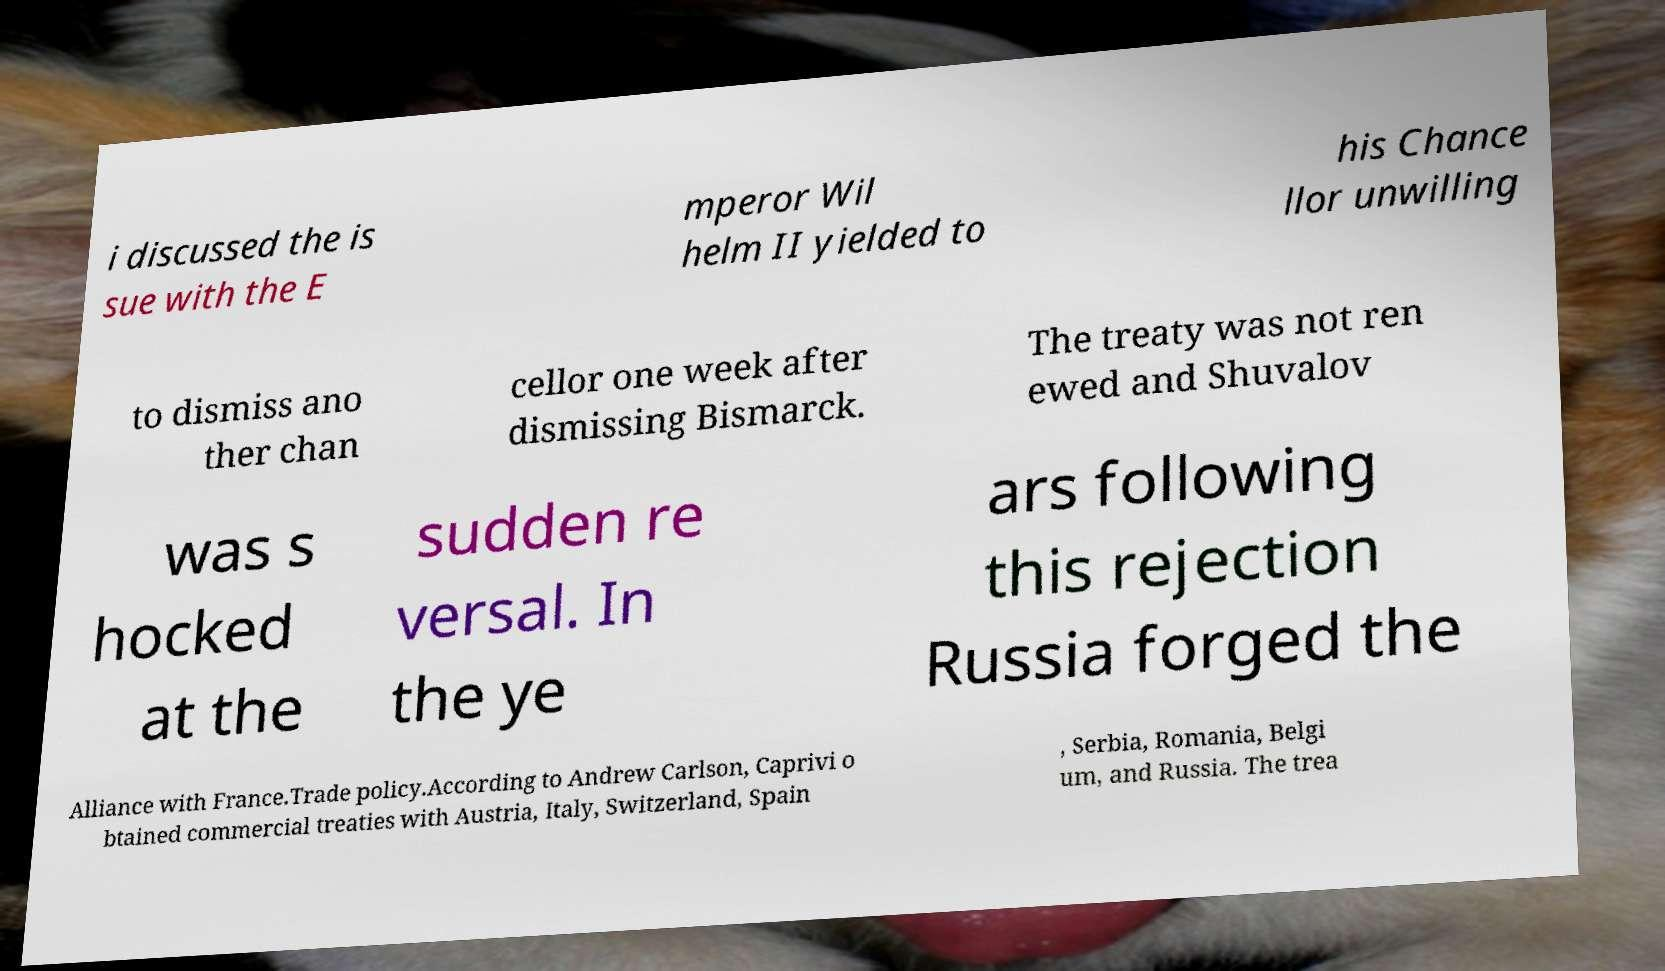Please identify and transcribe the text found in this image. i discussed the is sue with the E mperor Wil helm II yielded to his Chance llor unwilling to dismiss ano ther chan cellor one week after dismissing Bismarck. The treaty was not ren ewed and Shuvalov was s hocked at the sudden re versal. In the ye ars following this rejection Russia forged the Alliance with France.Trade policy.According to Andrew Carlson, Caprivi o btained commercial treaties with Austria, Italy, Switzerland, Spain , Serbia, Romania, Belgi um, and Russia. The trea 